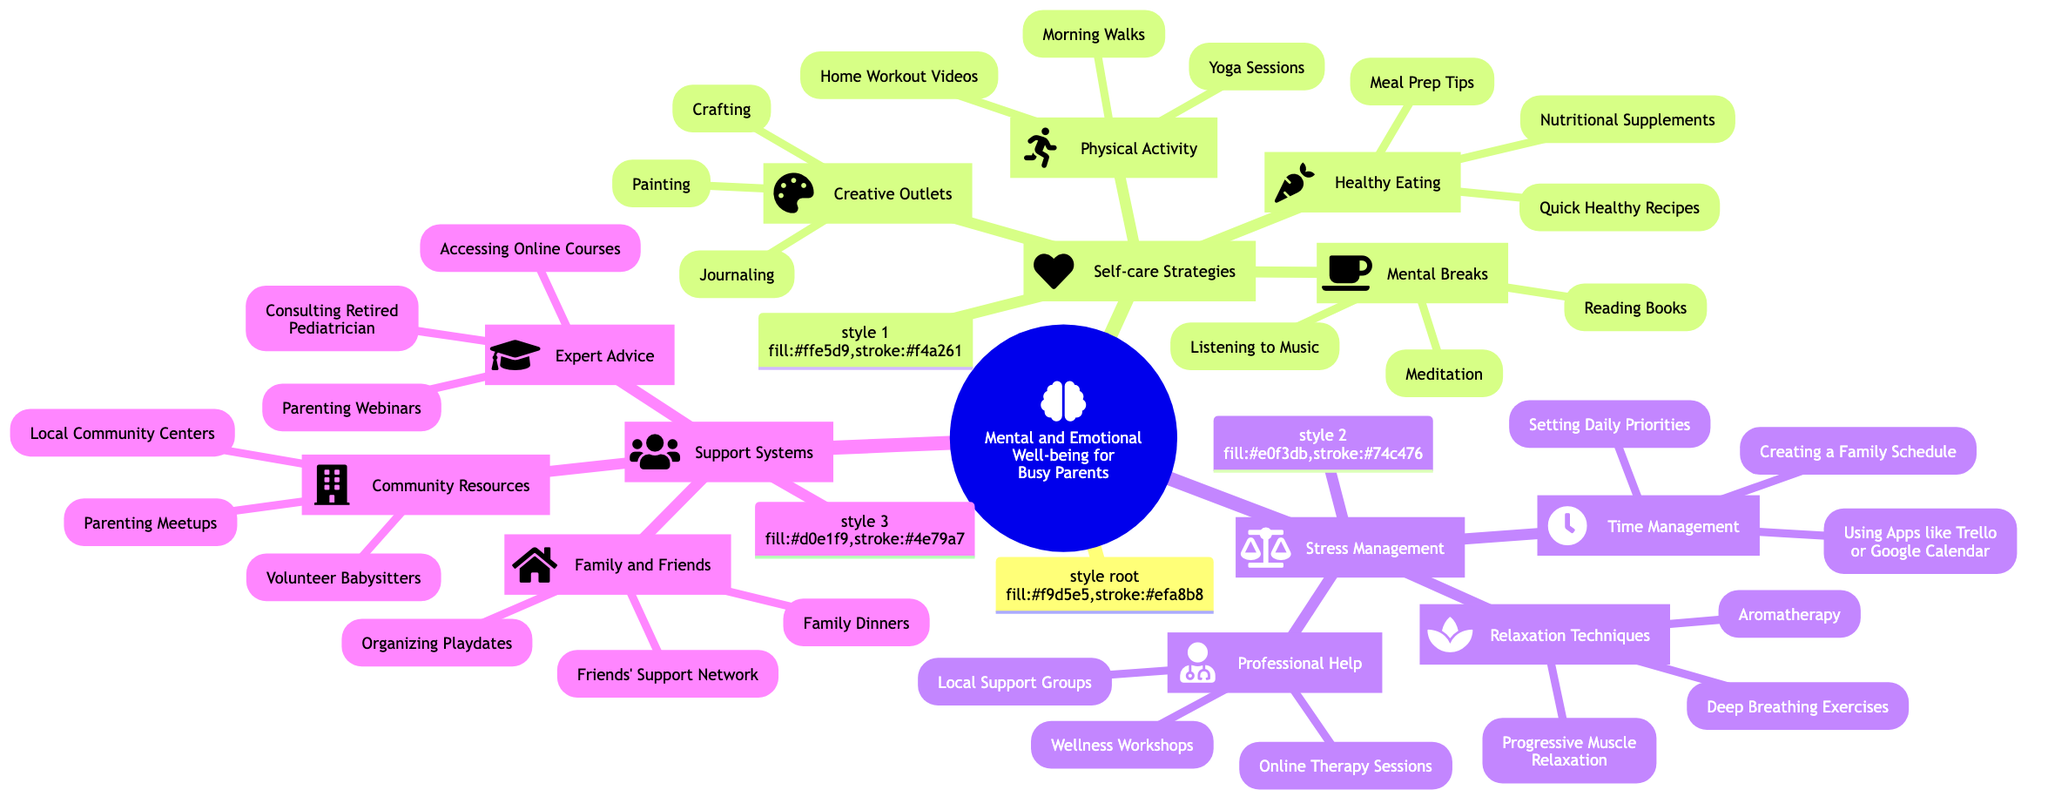What are the four main categories in the diagram? The diagram outlines three main categories related to mental and emotional well-being for busy parents: Self-care Strategies, Stress Management, and Support Systems.
Answer: Self-care Strategies, Stress Management, Support Systems How many subcategories are under Self-care Strategies? Under Self-care Strategies, there are four subcategories listed: Mental Breaks, Physical Activity, Creative Outlets, and Healthy Eating.
Answer: 4 What type of activities are included in Physical Activity? Physical Activity includes three specific activities: Morning Walks, Yoga Sessions, and Home Workout Videos.
Answer: Morning Walks, Yoga Sessions, Home Workout Videos Which support system category includes "Consulting Retired Pediatrician"? The category that includes "Consulting Retired Pediatrician" is Expert Advice, which is a subcategory of Support Systems.
Answer: Expert Advice Count the total number of activities listed under Stress Management. Under Stress Management, there are a total of 9 specific activities: three under Time Management, three under Relaxation Techniques, and three under Professional Help (3 + 3 + 3 = 9).
Answer: 9 What is one relaxation technique mentioned in the diagram? One relaxation technique mentioned is Deep Breathing Exercises, which is part of the Relaxation Techniques subcategory under Stress Management.
Answer: Deep Breathing Exercises Which two activities are suggested under Healthy Eating? The two activities suggested under Healthy Eating are Meal Prep Tips and Quick Healthy Recipes. There are three activities total, but the question only asks for two of them.
Answer: Meal Prep Tips, Quick Healthy Recipes How many expert advice options are listed under Support Systems? Under Support Systems in the Expert Advice category, there are three options: Consulting Retired Pediatrician, Parenting Webinars, and Accessing Online Courses.
Answer: 3 What icon represents Relaxation Techniques? The icon representing Relaxation Techniques is the spa icon, which visually indicates wellness and relaxation.
Answer: Spa icon 